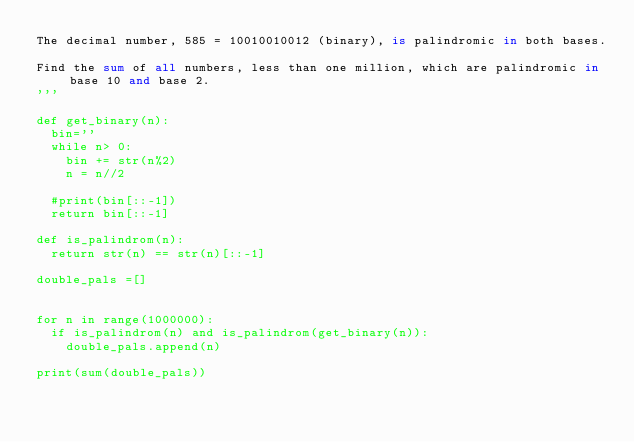<code> <loc_0><loc_0><loc_500><loc_500><_Python_>The decimal number, 585 = 10010010012 (binary), is palindromic in both bases.

Find the sum of all numbers, less than one million, which are palindromic in base 10 and base 2.
'''

def get_binary(n):
	bin=''
	while n> 0:
		bin += str(n%2)
		n = n//2
		
	#print(bin[::-1])
	return bin[::-1]
	
def is_palindrom(n):
	return str(n) == str(n)[::-1]
	
double_pals =[]


for n in range(1000000):
	if is_palindrom(n) and is_palindrom(get_binary(n)):
		double_pals.append(n)
	
print(sum(double_pals))
	
</code> 